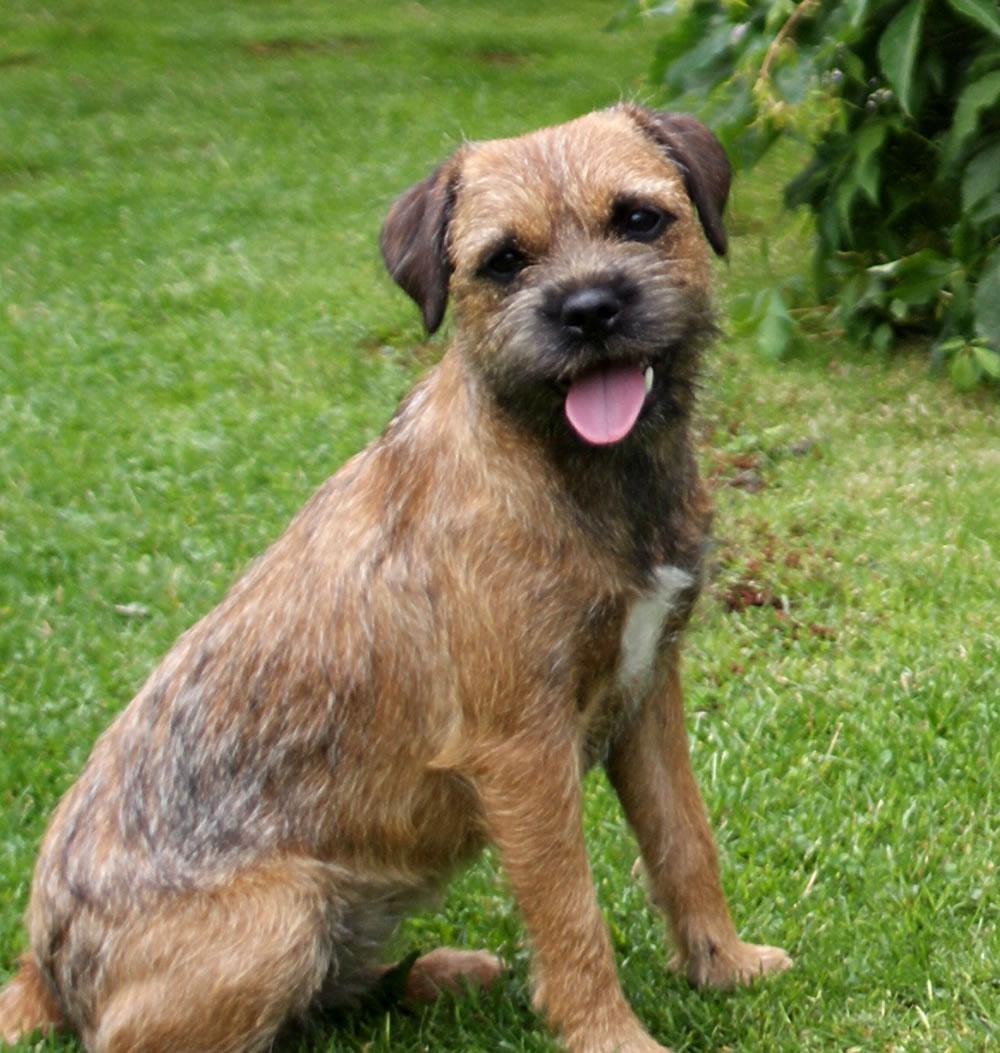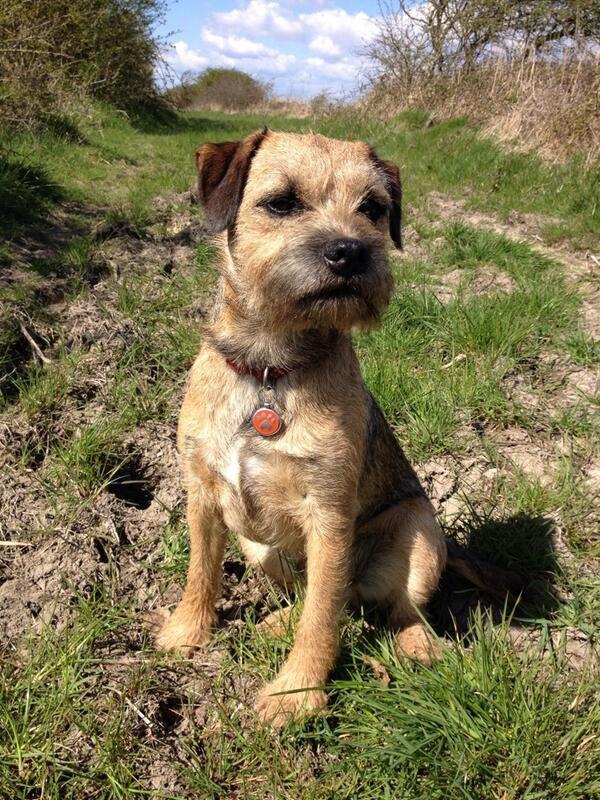The first image is the image on the left, the second image is the image on the right. Examine the images to the left and right. Is the description "Three dogs are relaxing outside in the grass." accurate? Answer yes or no. No. The first image is the image on the left, the second image is the image on the right. Evaluate the accuracy of this statement regarding the images: "There are three dogs exactly.". Is it true? Answer yes or no. No. 